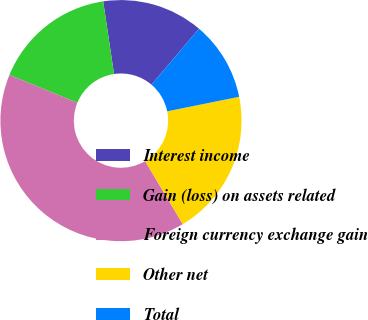Convert chart. <chart><loc_0><loc_0><loc_500><loc_500><pie_chart><fcel>Interest income<fcel>Gain (loss) on assets related<fcel>Foreign currency exchange gain<fcel>Other net<fcel>Total<nl><fcel>13.55%<fcel>16.46%<fcel>39.75%<fcel>19.6%<fcel>10.64%<nl></chart> 